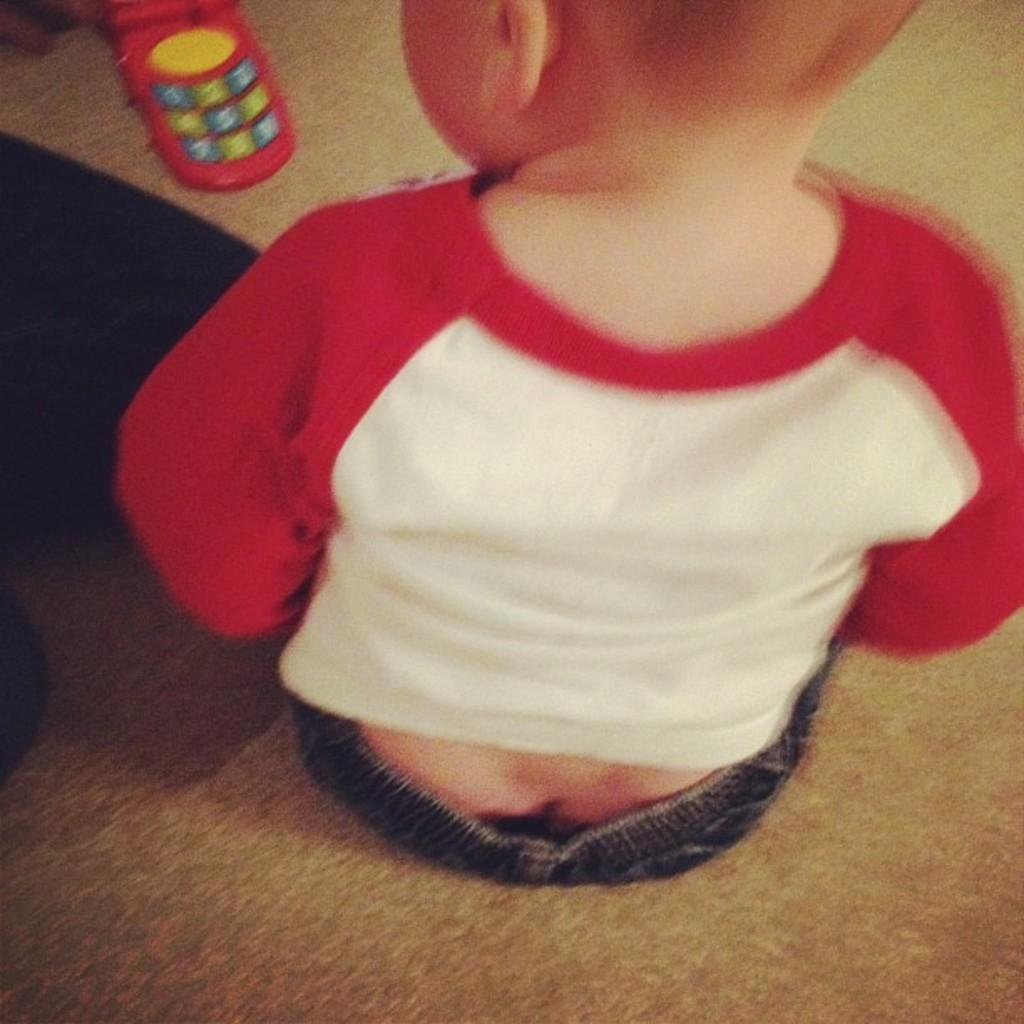Describe this image in one or two sentences. In this image we can see a kid sitting on the floor, and there is a toy cell phone. 